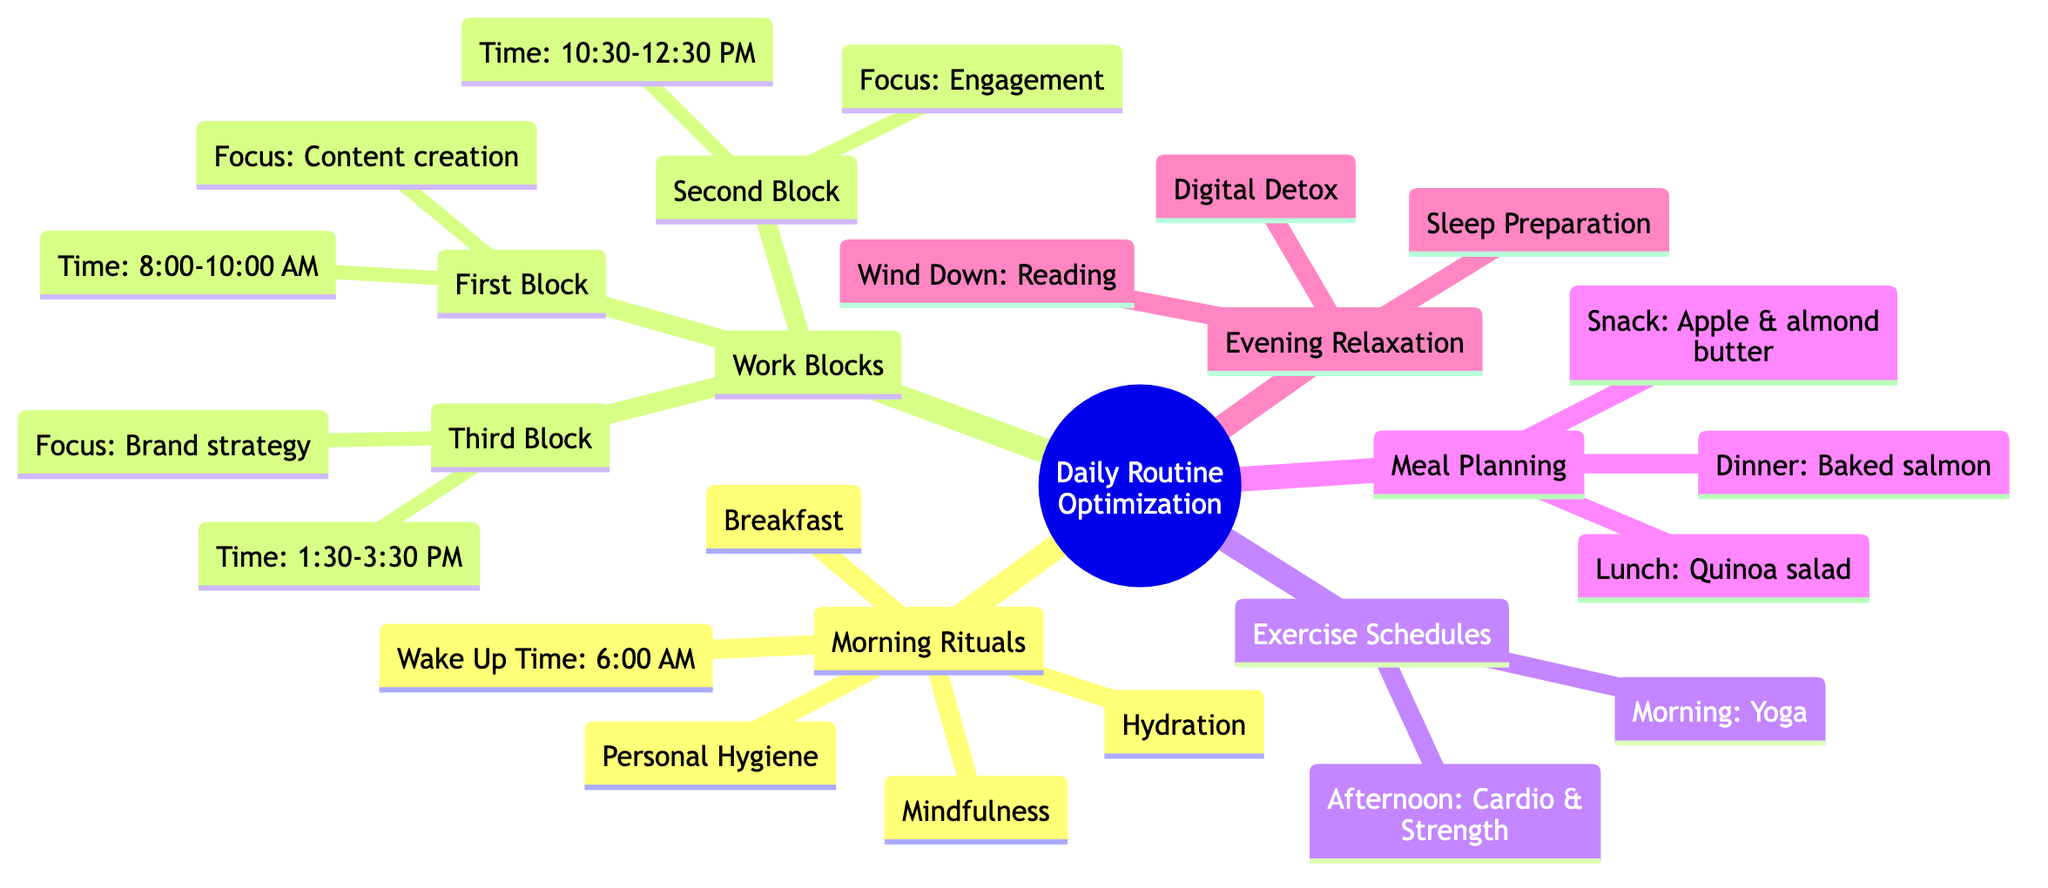What time is the morning workout scheduled? The diagram specifies the time for the morning workout, which is listed under "Exercise Schedules." It indicates that the workout occurs from 7:00 AM to 7:30 AM.
Answer: 7:00 AM - 7:30 AM What meal is planned for lunch? The meal for lunch is mentioned under "Meal Planning," where it states a "Quinoa salad with grilled chicken, avocado, and cherry tomatoes" for the corresponding time.
Answer: Quinoa salad with grilled chicken, avocado, and cherry tomatoes How long is the first work block? The first work block is defined in the "Work Blocks" section from 8:00 AM to 10:00 AM. The total duration can be calculated as 2 hours, which is the difference between the start and end times.
Answer: 2 hours What is the primary focus of the third work block? The third work block, listed in the "Work Blocks" section, specifies its focus as "Brand strategy and planning," which directly indicates the work being conducted during that time.
Answer: Brand strategy and planning What activity is scheduled at 9:00 PM? The diagram indicates that at 9:00 PM, there is a "Digital Detox" activity, which means turning off electronic devices. This clear indication provides precise knowledge of the activity at this time.
Answer: Turn off electronic devices How many meal types are planned during the day? From the "Meal Planning" section, three distinct meal types are identified: lunch, snack, and dinner. By counting these types, we find there are three meals planned.
Answer: 3 What is the method used for digital detoxing? Under the "Evening Relaxation" section, the method for the digital detox is detailed as using a "digital detox box." This provides specific information about how the detox is implemented.
Answer: Digital detox box What does the individual drink upon waking up? The "Morning Rituals" section specifies that the individual drinks "a glass of lemon water" immediately after waking up, thereby detailing their hydration practice.
Answer: A glass of lemon water At what time is the evening reading scheduled? The diagram outlines that reading is scheduled at 8:00 PM under "Evening Relaxation" in the "Wind Down" section, clearly marking the start time for this activity.
Answer: 8:00 PM 